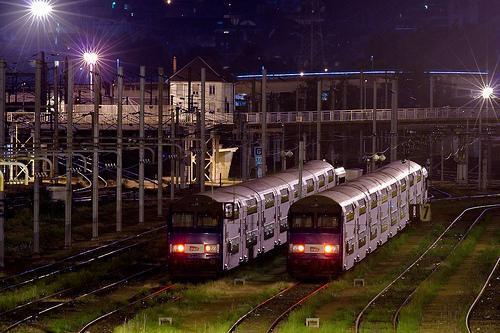How many trains are pictured?
Give a very brief answer. 2. 